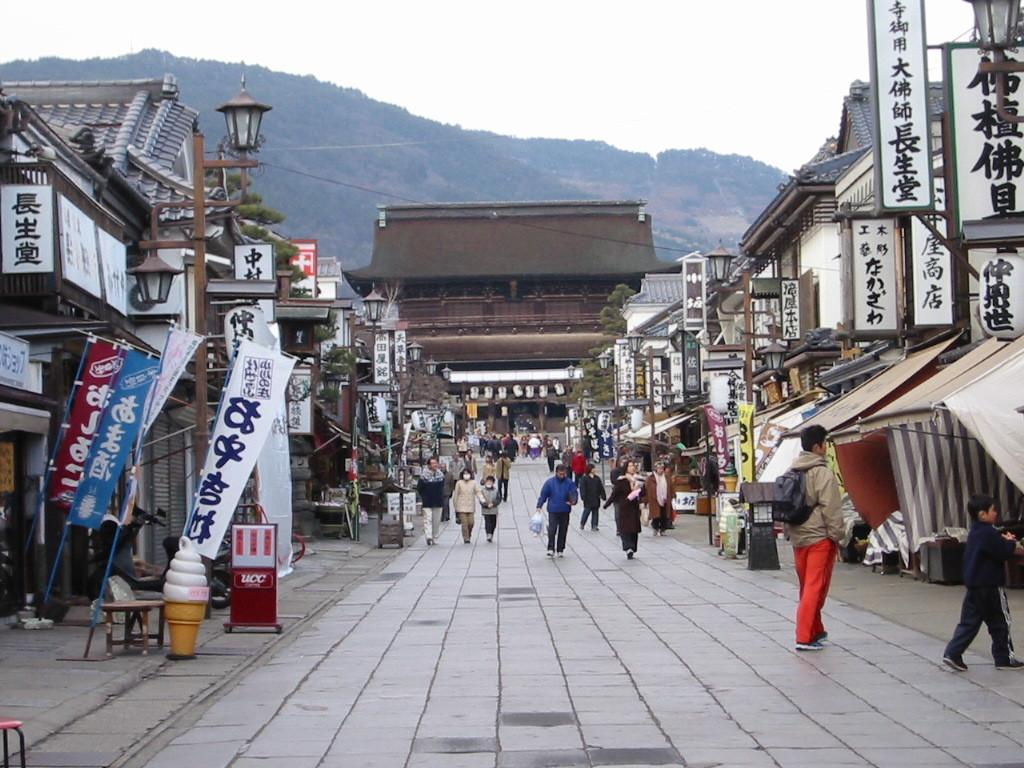What type of structures can be seen in the image? There are buildings in the image. What other objects can be seen in the image? There are poles, boards, banners, a table, chairs, and tents in the image. What type of natural elements are present in the image? There are trees in the image. Who or what is present in the image? There are people in the image. What can be seen in the background of the image? There is a mountain and sky visible in the background of the image. What type of plants are being served as a drink in the image? There is no drink or plants present in the image. What type of cream is being used to decorate the tents in the image? There is no cream or decoration on the tents in the image. 